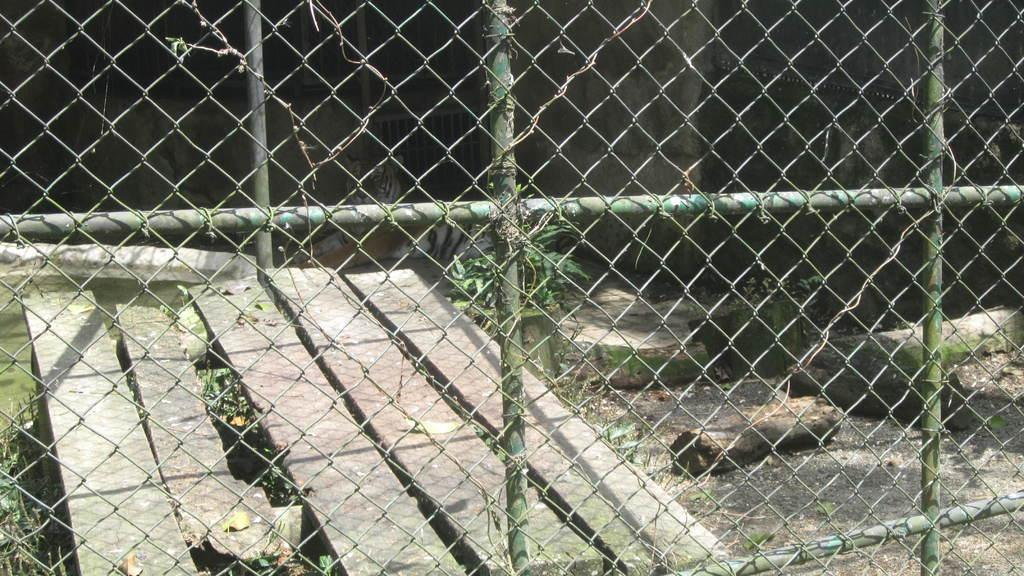What can be seen in the image that serves as a barrier or support? There is a railing in the image. What type of animal can be seen in the background of the image? There is an animal in the background of the image, and it is white and black in color. What type of vegetation is present in the image? There are plants in the image, and they are green in color. Can you describe the nest of the animal in the image? There is no nest present in the image; only the animal and its color are mentioned. What type of fruit is hanging from the plants in the image? There is no fruit, specifically quince, present in the image; only green plants are mentioned. 